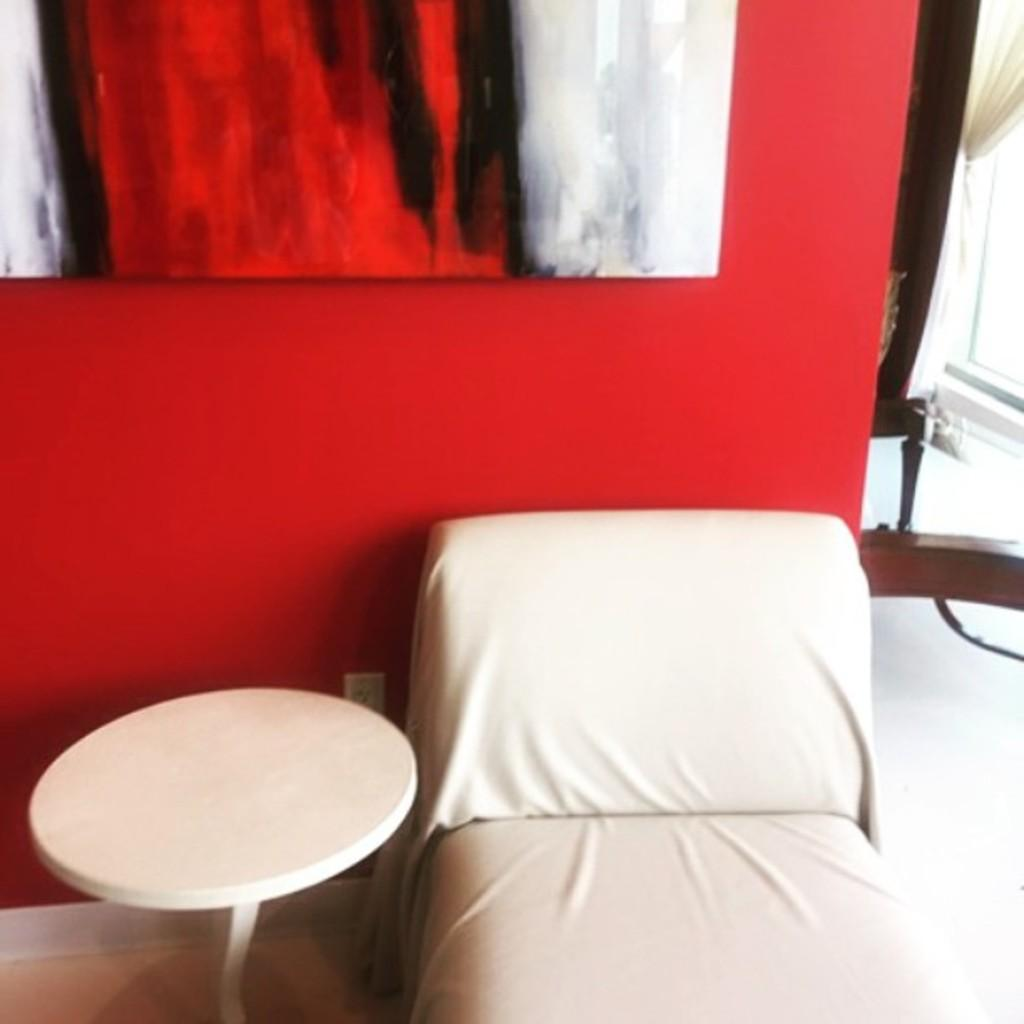What type of furniture is present in the image? There is a side table in the image. What type of object is used for comfort and support in the image? There is a pillow in the image. What type of bed is present in the image? There is a cot in the image. What type of hydrant can be seen in the image? There is no hydrant present in the image. What type of lace is used to decorate the pillow in the image? There is no lace present on the pillow in the image. 